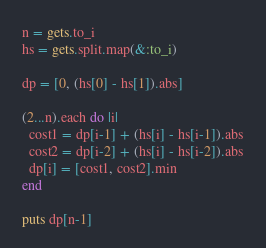<code> <loc_0><loc_0><loc_500><loc_500><_Ruby_>n = gets.to_i
hs = gets.split.map(&:to_i)

dp = [0, (hs[0] - hs[1]).abs]

(2...n).each do |i|
  cost1 = dp[i-1] + (hs[i] - hs[i-1]).abs
  cost2 = dp[i-2] + (hs[i] - hs[i-2]).abs
  dp[i] = [cost1, cost2].min
end

puts dp[n-1]
</code> 